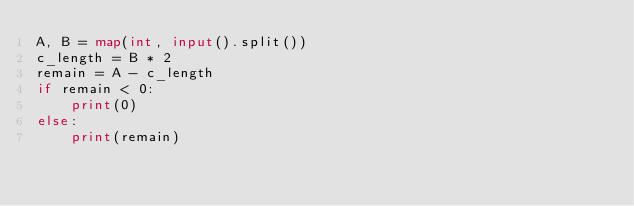Convert code to text. <code><loc_0><loc_0><loc_500><loc_500><_Python_>A, B = map(int, input().split())
c_length = B * 2
remain = A - c_length
if remain < 0:
    print(0)
else:
    print(remain)</code> 